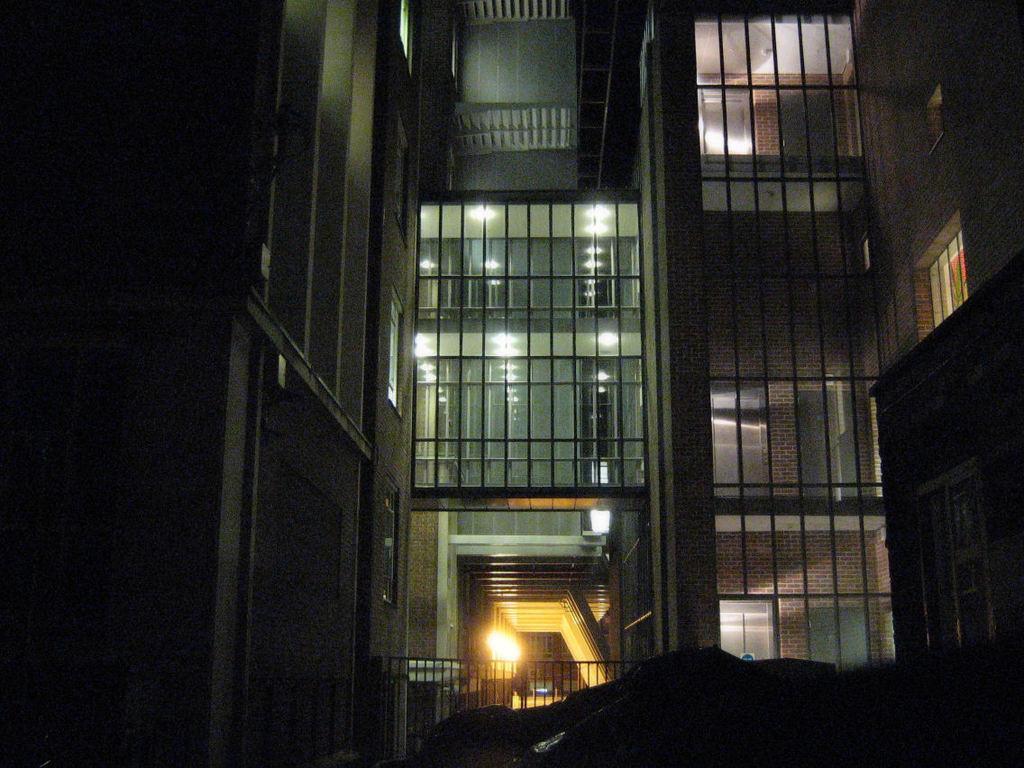In one or two sentences, can you explain what this image depicts? In this image we can see a building, lights, and glasses. 